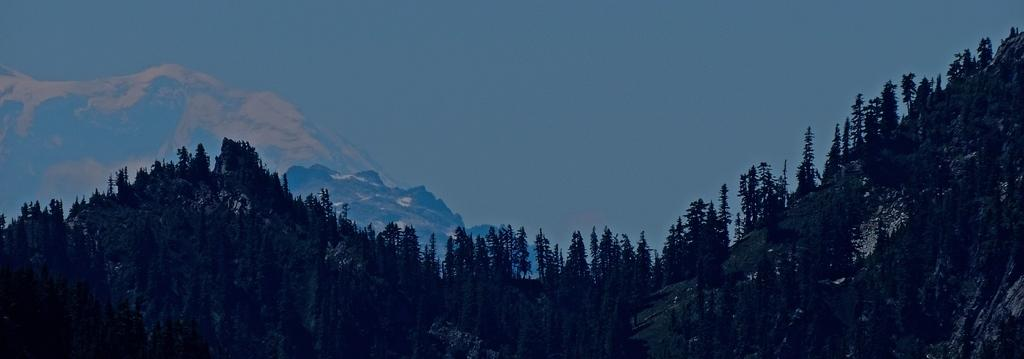What type of vegetation can be seen on the mountains in the image? There are trees on the mountains in the image. What geographical feature is visible in the background of the image? There are mountains visible in the background of the image. What is visible at the top of the image? The sky is visible at the top of the image. How would you describe the lighting in the bottom part of the image? The bottom part of the image appears to be dark. How does the coach show respect to the trees on the mountains in the image? There is no coach present in the image, and therefore no such interaction can be observed. What type of finger can be seen pointing at the mountains in the image? There are no fingers visible in the image; it only shows trees on the mountains and the sky. 